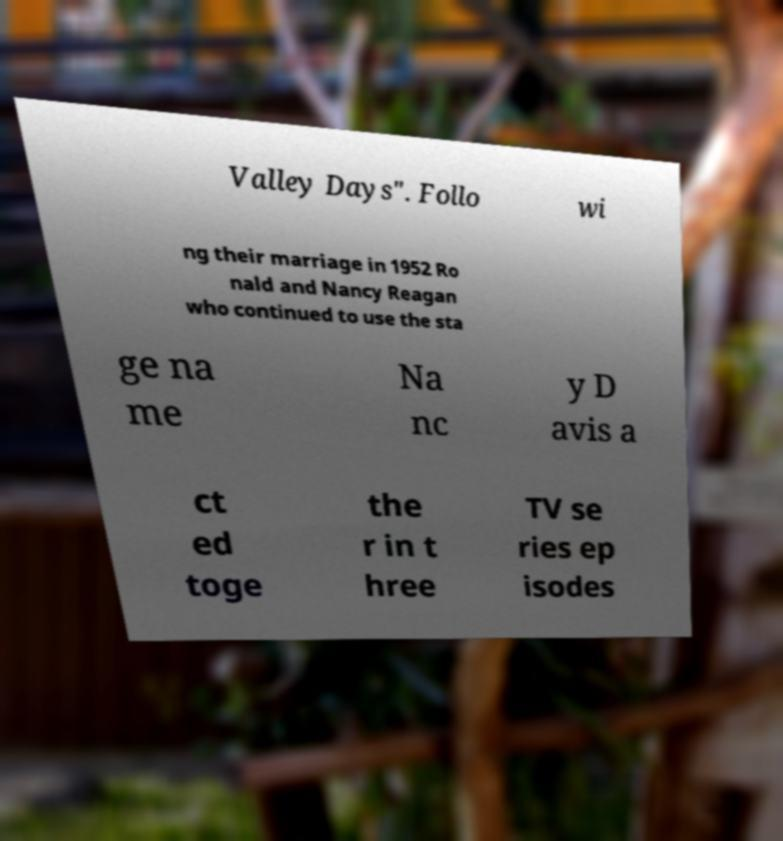I need the written content from this picture converted into text. Can you do that? Valley Days". Follo wi ng their marriage in 1952 Ro nald and Nancy Reagan who continued to use the sta ge na me Na nc y D avis a ct ed toge the r in t hree TV se ries ep isodes 